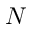Convert formula to latex. <formula><loc_0><loc_0><loc_500><loc_500>N</formula> 